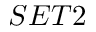Convert formula to latex. <formula><loc_0><loc_0><loc_500><loc_500>S E T 2</formula> 